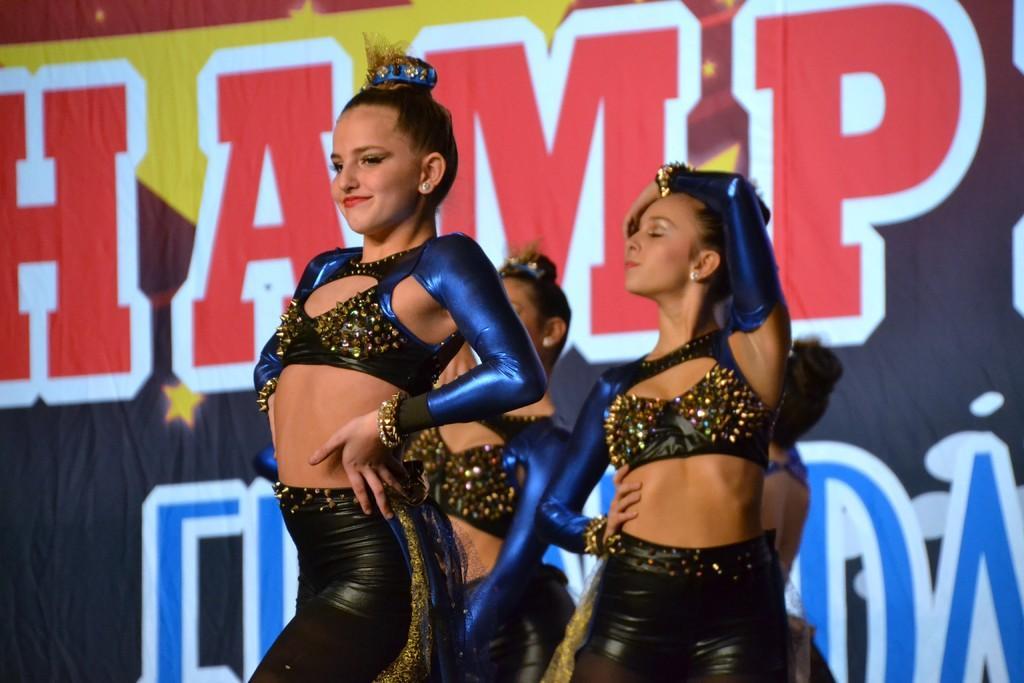Describe this image in one or two sentences. In this image there are four women who are dancing on the stage by wearing the costumes. In the background there is a banner. They are wearing the costume which is the combination of black and blue. 